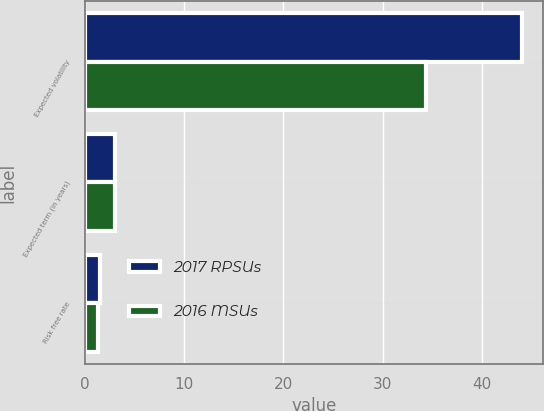<chart> <loc_0><loc_0><loc_500><loc_500><stacked_bar_chart><ecel><fcel>Expected volatility<fcel>Expected term (in years)<fcel>Risk free rate<nl><fcel>2017 RPSUs<fcel>43.96<fcel>3<fcel>1.5<nl><fcel>2016 MSUs<fcel>34.33<fcel>3<fcel>1.31<nl></chart> 